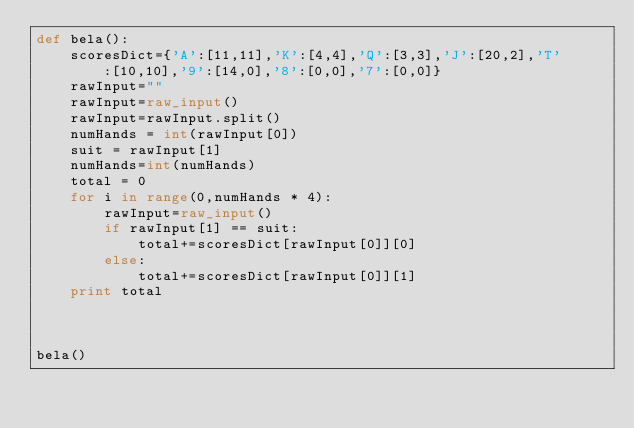Convert code to text. <code><loc_0><loc_0><loc_500><loc_500><_Python_>def bela():
    scoresDict={'A':[11,11],'K':[4,4],'Q':[3,3],'J':[20,2],'T':[10,10],'9':[14,0],'8':[0,0],'7':[0,0]}
    rawInput=""
    rawInput=raw_input()
    rawInput=rawInput.split()
    numHands = int(rawInput[0])
    suit = rawInput[1]
    numHands=int(numHands)
    total = 0
    for i in range(0,numHands * 4):
        rawInput=raw_input()
        if rawInput[1] == suit:
            total+=scoresDict[rawInput[0]][0]
        else:
            total+=scoresDict[rawInput[0]][1]
    print total
        
        
    
bela()</code> 